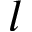Convert formula to latex. <formula><loc_0><loc_0><loc_500><loc_500>l</formula> 